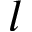Convert formula to latex. <formula><loc_0><loc_0><loc_500><loc_500>l</formula> 